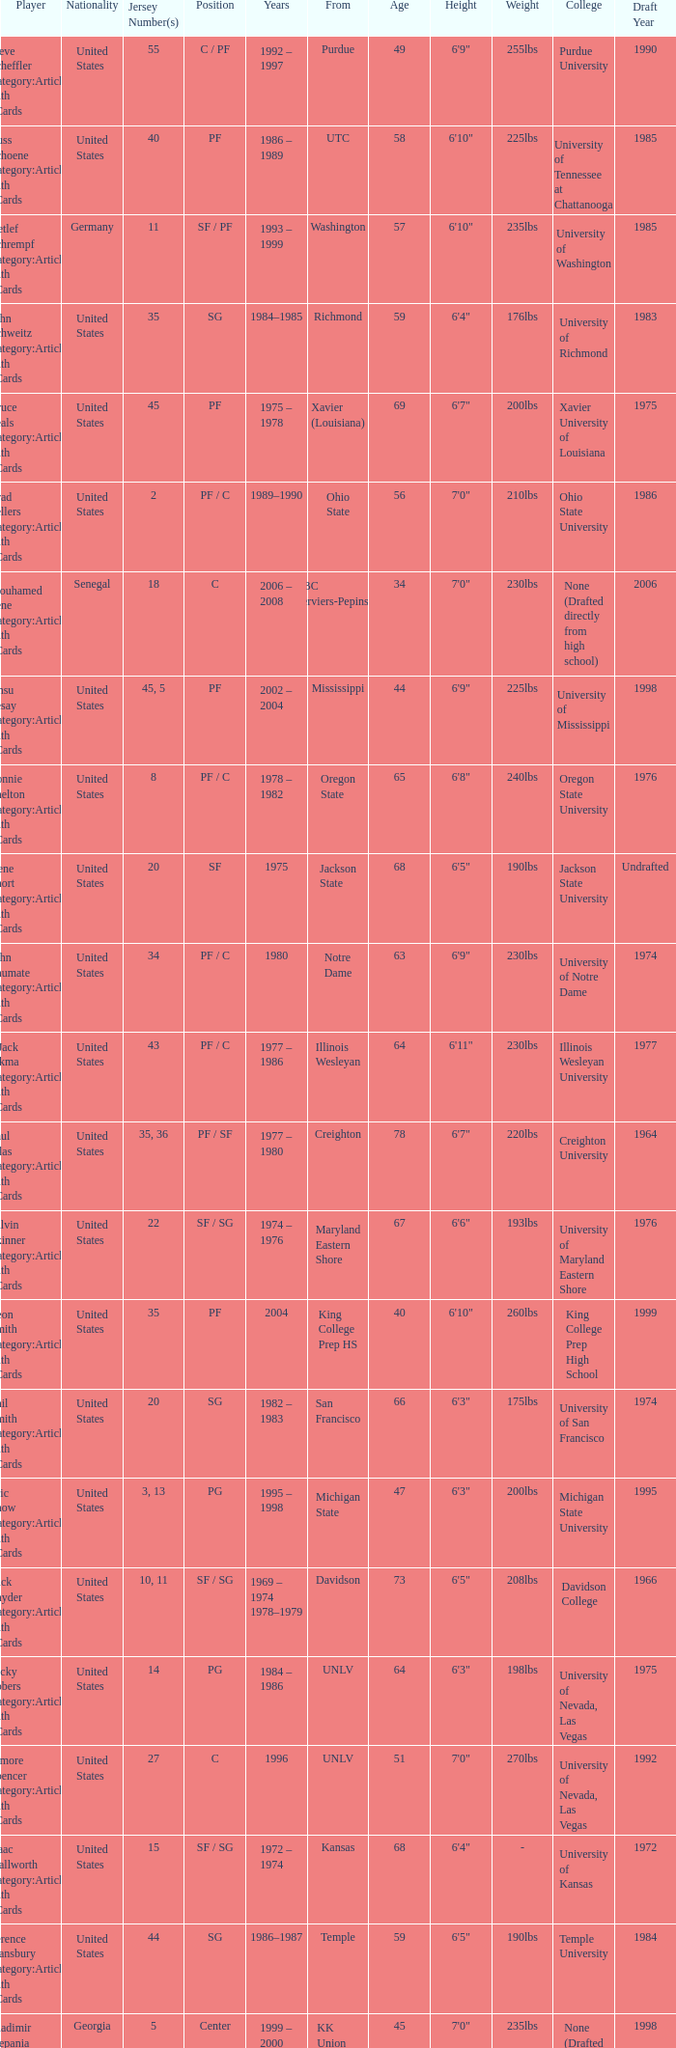Who wears the jersey number 20 and has the position of SG? Phil Smith Category:Articles with hCards, Jon Sundvold Category:Articles with hCards. 